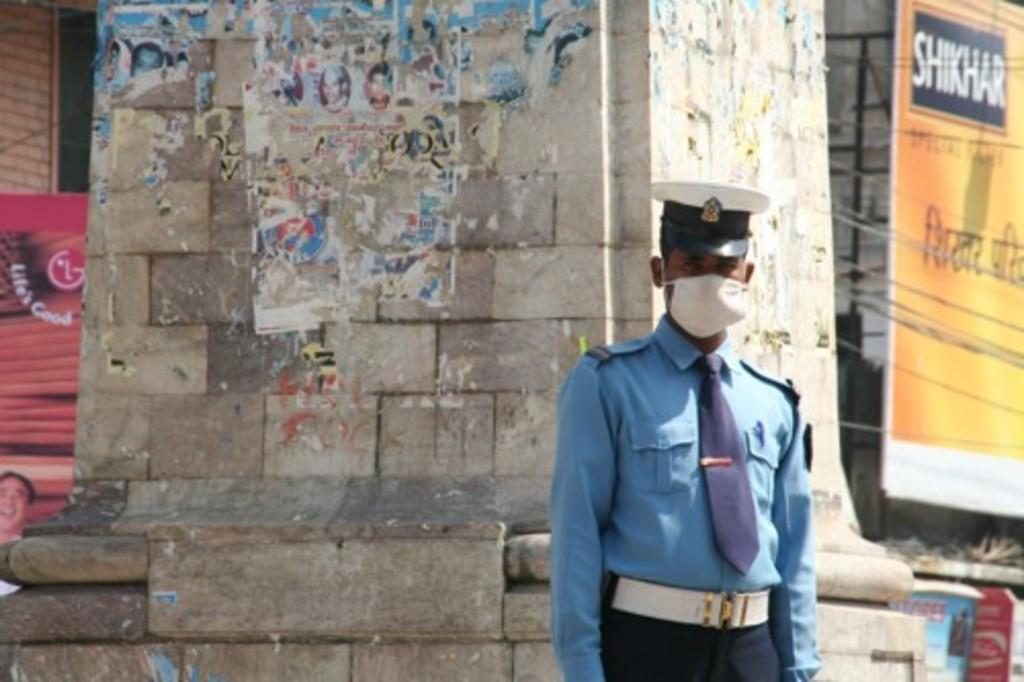What is the main subject of the image? There is a person standing in the image. What can be seen behind the person? There is a pillar behind the person. What is visible in the background of the image? There is a building with banners and text in the background. What objects are present on the surface in the image? There are objects on the surface in the image. What type of eye is depicted in the argument on the banner in the image? There is no eye or argument present on the banner in the image; it contains text and possibly images related to the building or event. 